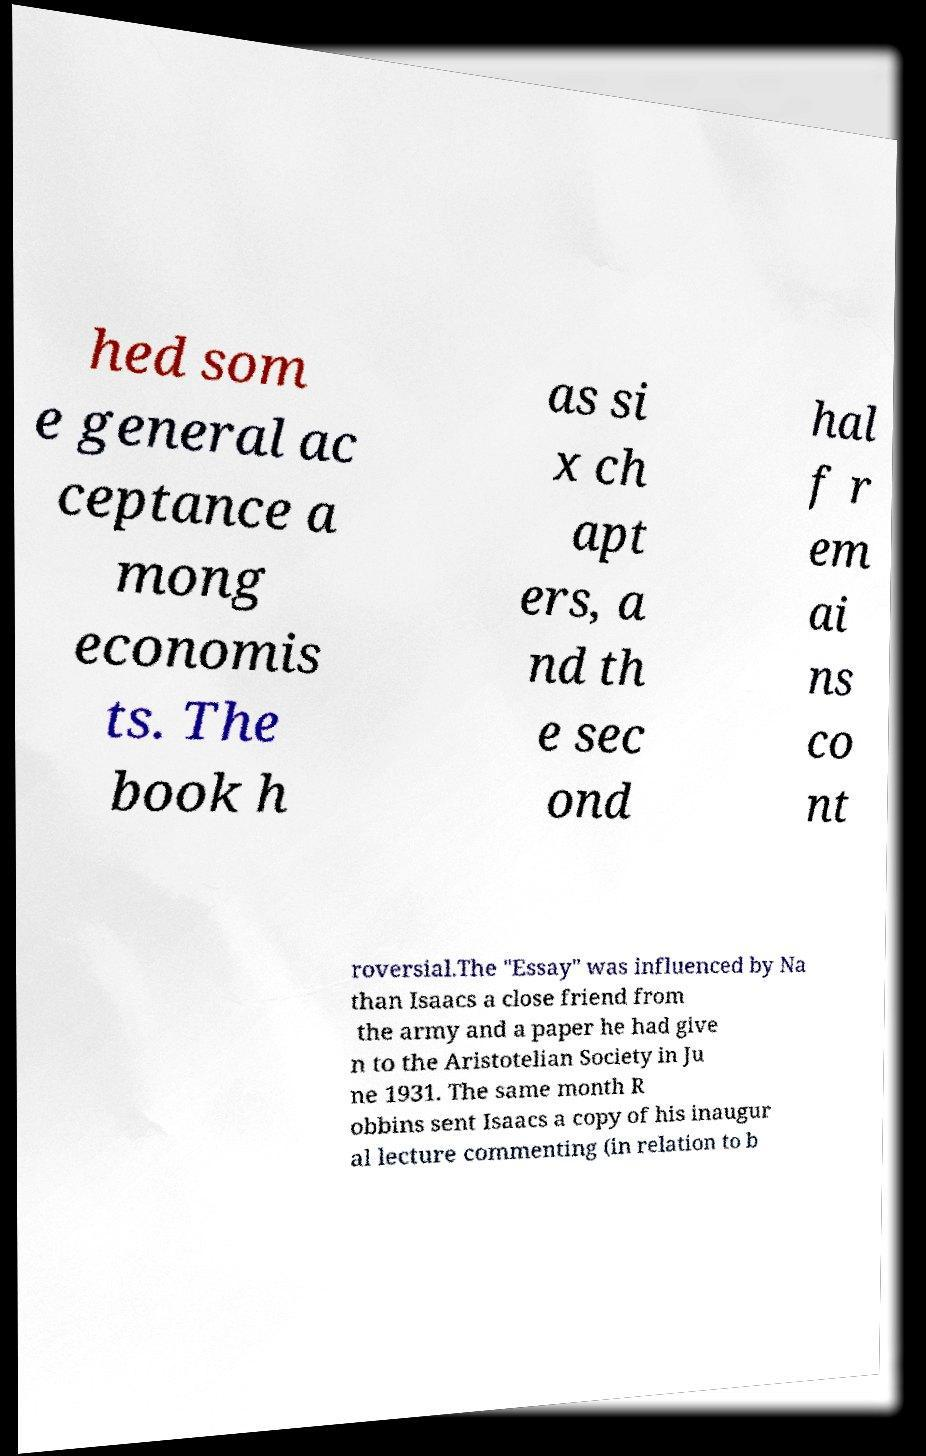There's text embedded in this image that I need extracted. Can you transcribe it verbatim? hed som e general ac ceptance a mong economis ts. The book h as si x ch apt ers, a nd th e sec ond hal f r em ai ns co nt roversial.The "Essay" was influenced by Na than Isaacs a close friend from the army and a paper he had give n to the Aristotelian Society in Ju ne 1931. The same month R obbins sent Isaacs a copy of his inaugur al lecture commenting (in relation to b 